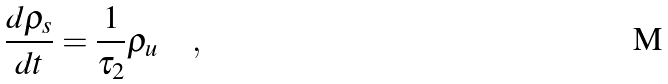Convert formula to latex. <formula><loc_0><loc_0><loc_500><loc_500>\frac { d \rho _ { s } } { d t } = \frac { 1 } { \tau _ { 2 } } \rho _ { u } \quad ,</formula> 